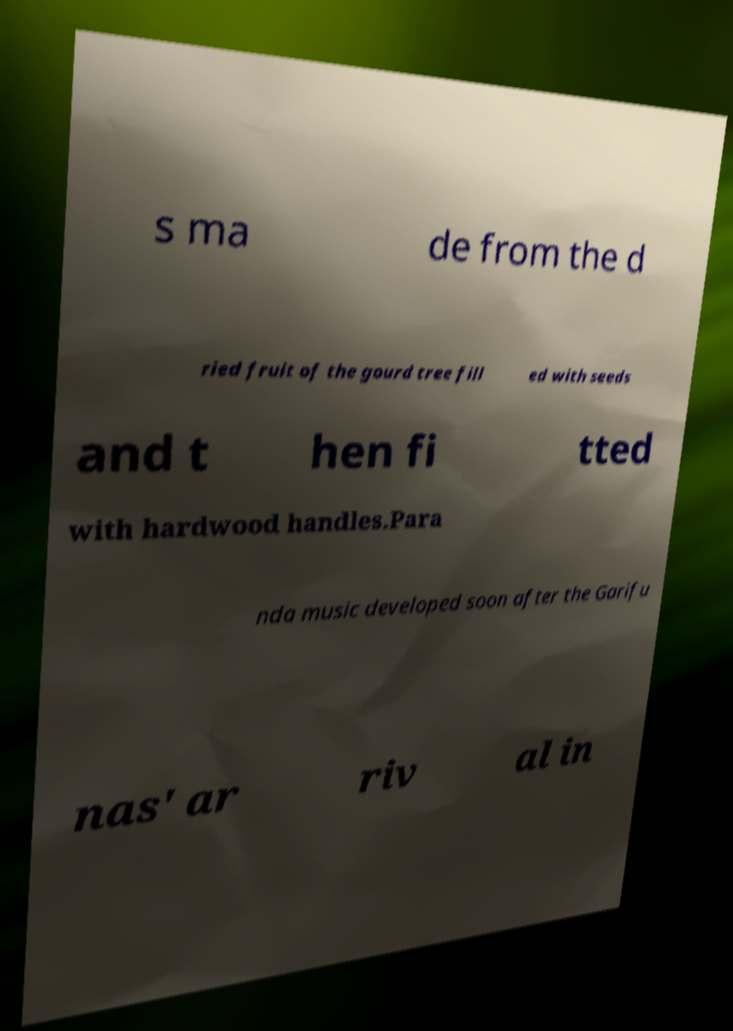Can you accurately transcribe the text from the provided image for me? s ma de from the d ried fruit of the gourd tree fill ed with seeds and t hen fi tted with hardwood handles.Para nda music developed soon after the Garifu nas' ar riv al in 